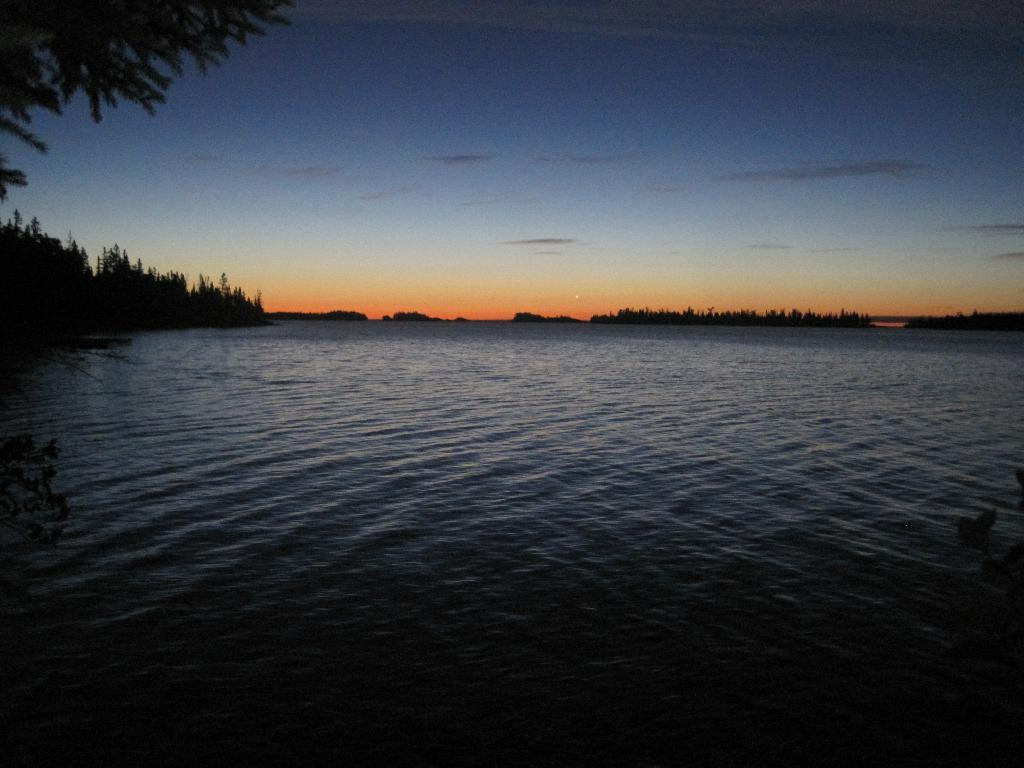What is the primary element in the image? There is water in the image. What type of vegetation is present around the water? There are trees around the water. What can be seen in the background of the image? The sky is visible in the background of the image. How many beads are floating on the water in the image? There are no beads present in the image; it only features water, trees, and the sky. 